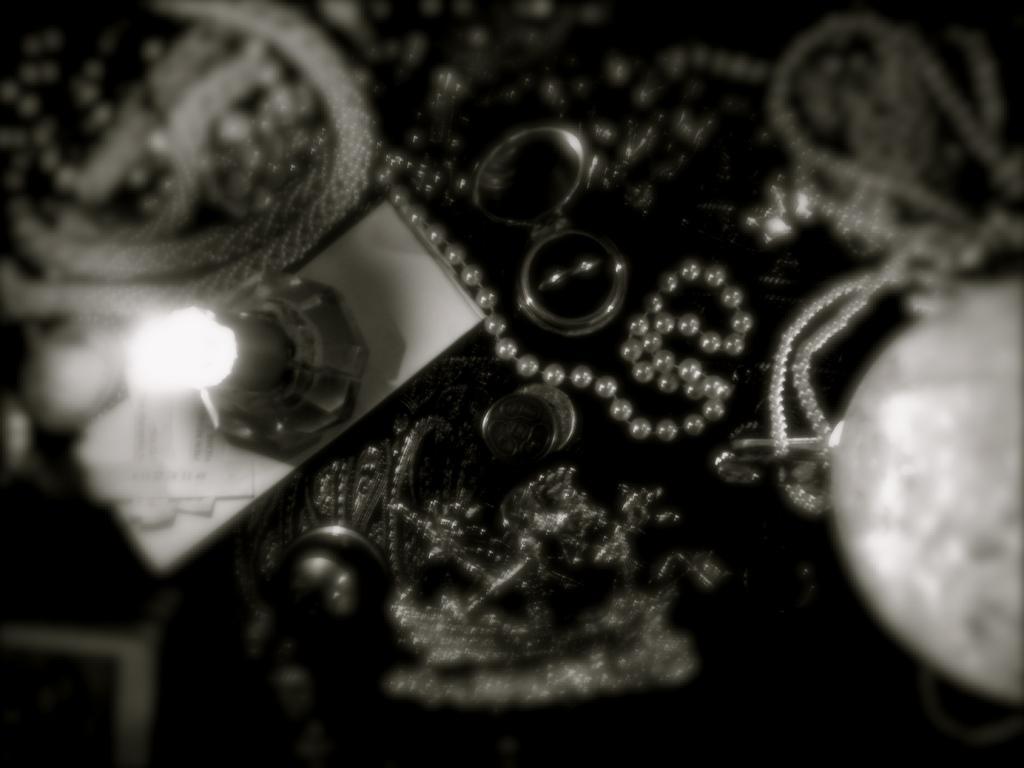In one or two sentences, can you explain what this image depicts? This is a black and white image. In this picture we can see lamp, paper, chains, ring, box and some objects. 